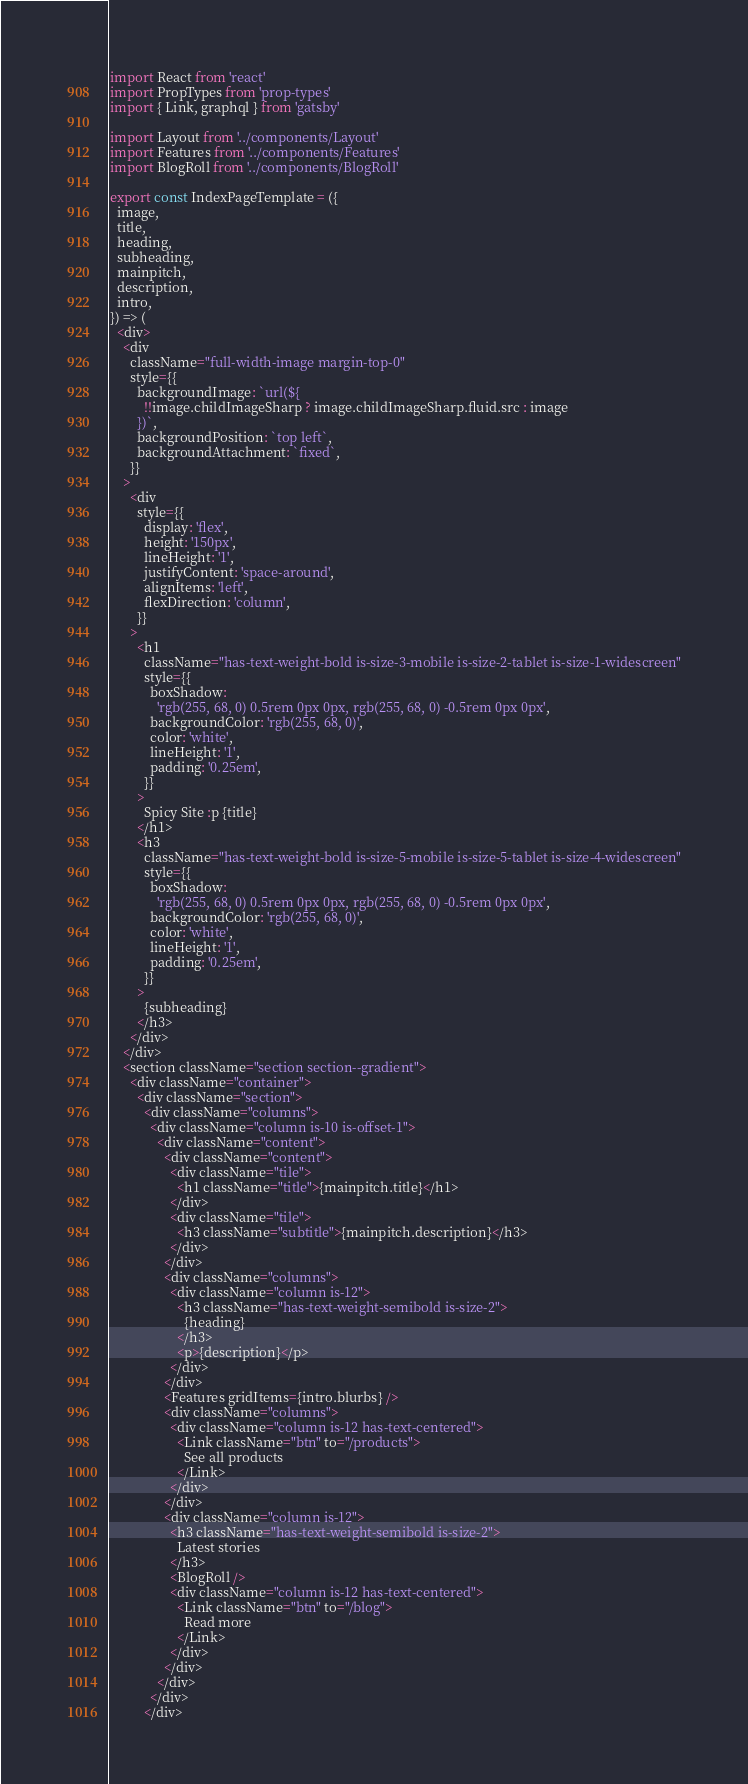Convert code to text. <code><loc_0><loc_0><loc_500><loc_500><_JavaScript_>import React from 'react'
import PropTypes from 'prop-types'
import { Link, graphql } from 'gatsby'

import Layout from '../components/Layout'
import Features from '../components/Features'
import BlogRoll from '../components/BlogRoll'

export const IndexPageTemplate = ({
  image,
  title,
  heading,
  subheading,
  mainpitch,
  description,
  intro,
}) => (
  <div>
    <div
      className="full-width-image margin-top-0"
      style={{
        backgroundImage: `url(${
          !!image.childImageSharp ? image.childImageSharp.fluid.src : image
        })`,
        backgroundPosition: `top left`,
        backgroundAttachment: `fixed`,
      }}
    >
      <div
        style={{
          display: 'flex',
          height: '150px',
          lineHeight: '1',
          justifyContent: 'space-around',
          alignItems: 'left',
          flexDirection: 'column',
        }}
      >
        <h1
          className="has-text-weight-bold is-size-3-mobile is-size-2-tablet is-size-1-widescreen"
          style={{
            boxShadow:
              'rgb(255, 68, 0) 0.5rem 0px 0px, rgb(255, 68, 0) -0.5rem 0px 0px',
            backgroundColor: 'rgb(255, 68, 0)',
            color: 'white',
            lineHeight: '1',
            padding: '0.25em',
          }}
        >
          Spicy Site :p {title}
        </h1>
        <h3
          className="has-text-weight-bold is-size-5-mobile is-size-5-tablet is-size-4-widescreen"
          style={{
            boxShadow:
              'rgb(255, 68, 0) 0.5rem 0px 0px, rgb(255, 68, 0) -0.5rem 0px 0px',
            backgroundColor: 'rgb(255, 68, 0)',
            color: 'white',
            lineHeight: '1',
            padding: '0.25em',
          }}
        >
          {subheading}
        </h3>
      </div>
    </div>
    <section className="section section--gradient">
      <div className="container">
        <div className="section">
          <div className="columns">
            <div className="column is-10 is-offset-1">
              <div className="content">
                <div className="content">
                  <div className="tile">
                    <h1 className="title">{mainpitch.title}</h1>
                  </div>
                  <div className="tile">
                    <h3 className="subtitle">{mainpitch.description}</h3>
                  </div>
                </div>
                <div className="columns">
                  <div className="column is-12">
                    <h3 className="has-text-weight-semibold is-size-2">
                      {heading}
                    </h3>
                    <p>{description}</p>
                  </div>
                </div>
                <Features gridItems={intro.blurbs} />
                <div className="columns">
                  <div className="column is-12 has-text-centered">
                    <Link className="btn" to="/products">
                      See all products
                    </Link>
                  </div>
                </div>
                <div className="column is-12">
                  <h3 className="has-text-weight-semibold is-size-2">
                    Latest stories
                  </h3>
                  <BlogRoll />
                  <div className="column is-12 has-text-centered">
                    <Link className="btn" to="/blog">
                      Read more
                    </Link>
                  </div>
                </div>
              </div>
            </div>
          </div></code> 